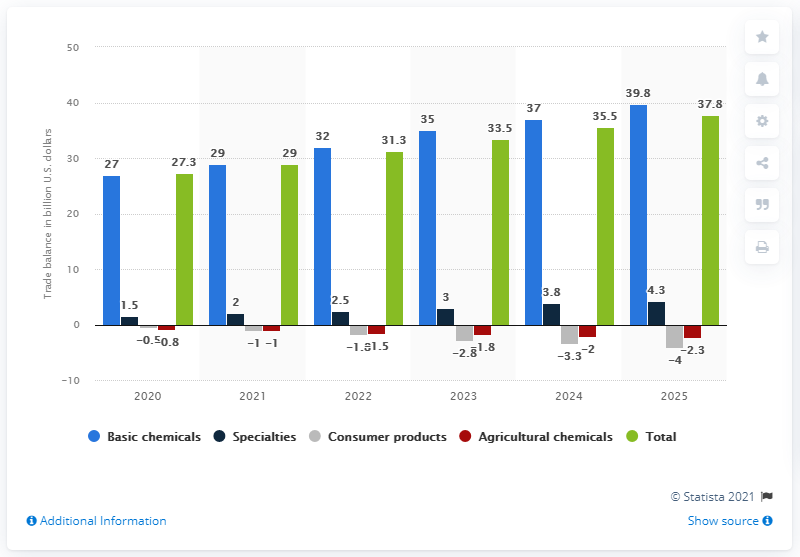List a handful of essential elements in this visual. The expected trade balance of the basic chemicals segment in the United States for 2025 is projected to be $39.8 billion. The trade balance of the basic chemicals segment is expected to total 39.8 billion U.S. dollars in the year 2025. 